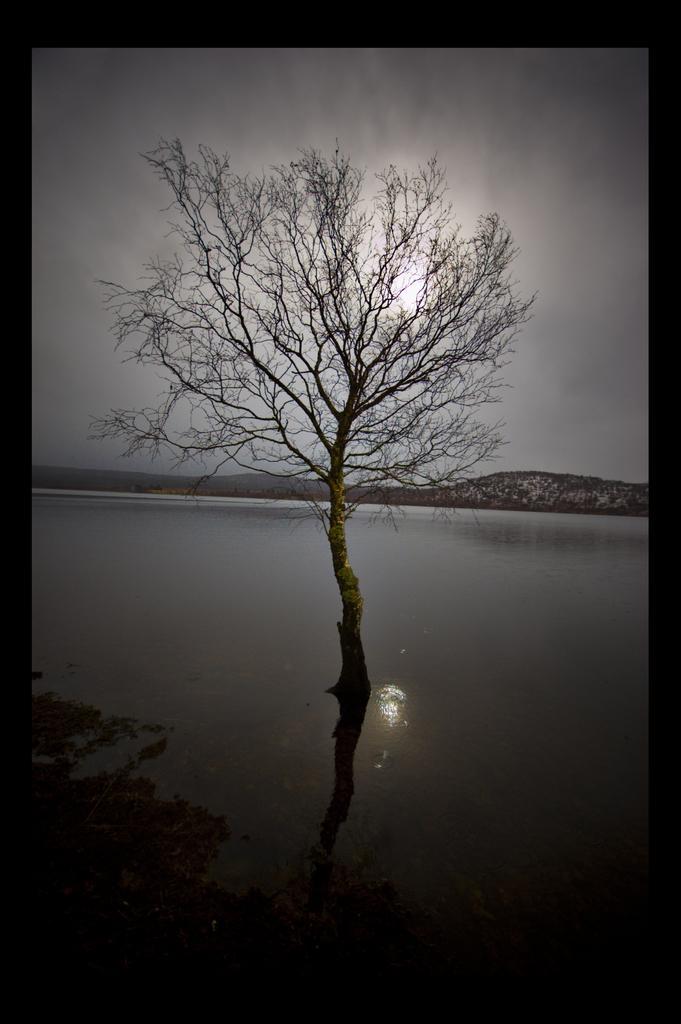How would you summarize this image in a sentence or two? There is a tree in the river. In the background we can observe hills here. There is a sky and sun with some black clouds all over the sky. 